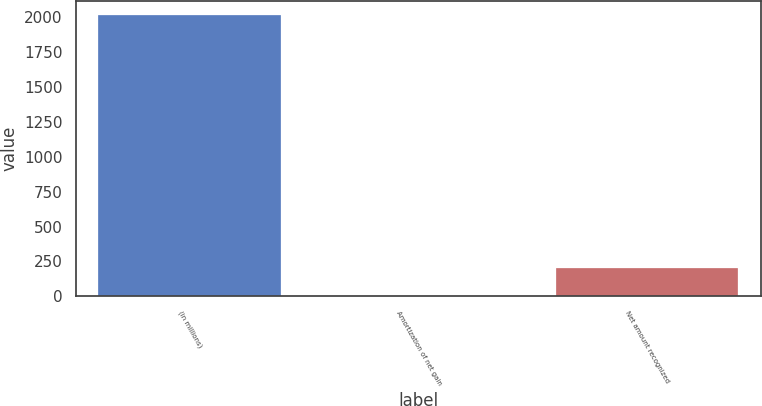<chart> <loc_0><loc_0><loc_500><loc_500><bar_chart><fcel>(in millions)<fcel>Amortization of net gain<fcel>Net amount recognized<nl><fcel>2015<fcel>3<fcel>204.2<nl></chart> 